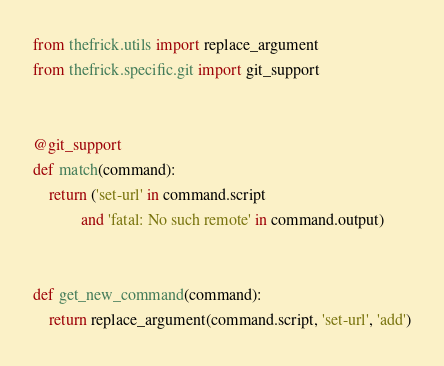Convert code to text. <code><loc_0><loc_0><loc_500><loc_500><_Python_>from thefrick.utils import replace_argument
from thefrick.specific.git import git_support


@git_support
def match(command):
    return ('set-url' in command.script
            and 'fatal: No such remote' in command.output)


def get_new_command(command):
    return replace_argument(command.script, 'set-url', 'add')
</code> 